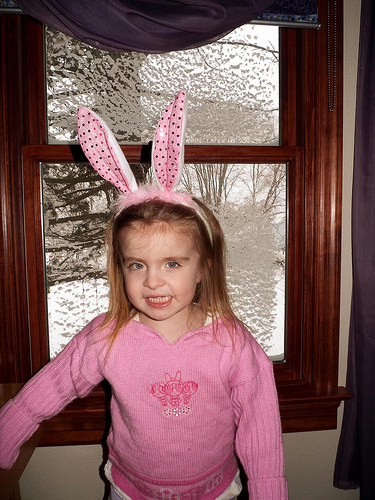<image>
Is the bunny ears under the curtain? Yes. The bunny ears is positioned underneath the curtain, with the curtain above it in the vertical space. Where is the girl in relation to the window? Is it behind the window? No. The girl is not behind the window. From this viewpoint, the girl appears to be positioned elsewhere in the scene. 